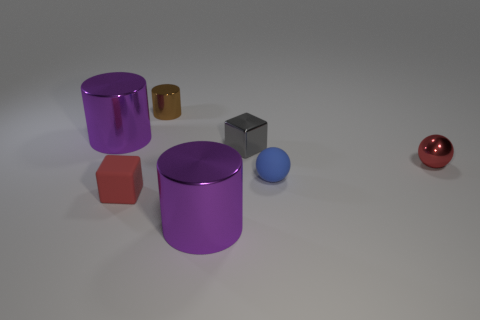Can you describe the colors of the objects and how they might relate to their perceived textures? Certainly, the colors of the objects in the image range from vivid purples, reds, and blues to more muted grays and browns. These colors can influence our perception of texture, with shiny objects often appearing in more vivid colors and matte objects in muted tones. The reflective surfaces of the purple cylinder and red sphere suggest a smooth and possibly metallic or plastic texture; whereas, the matte finish of the brown and gray cubes implies a texture that could be likened to stone, ceramic, or some plastics. 